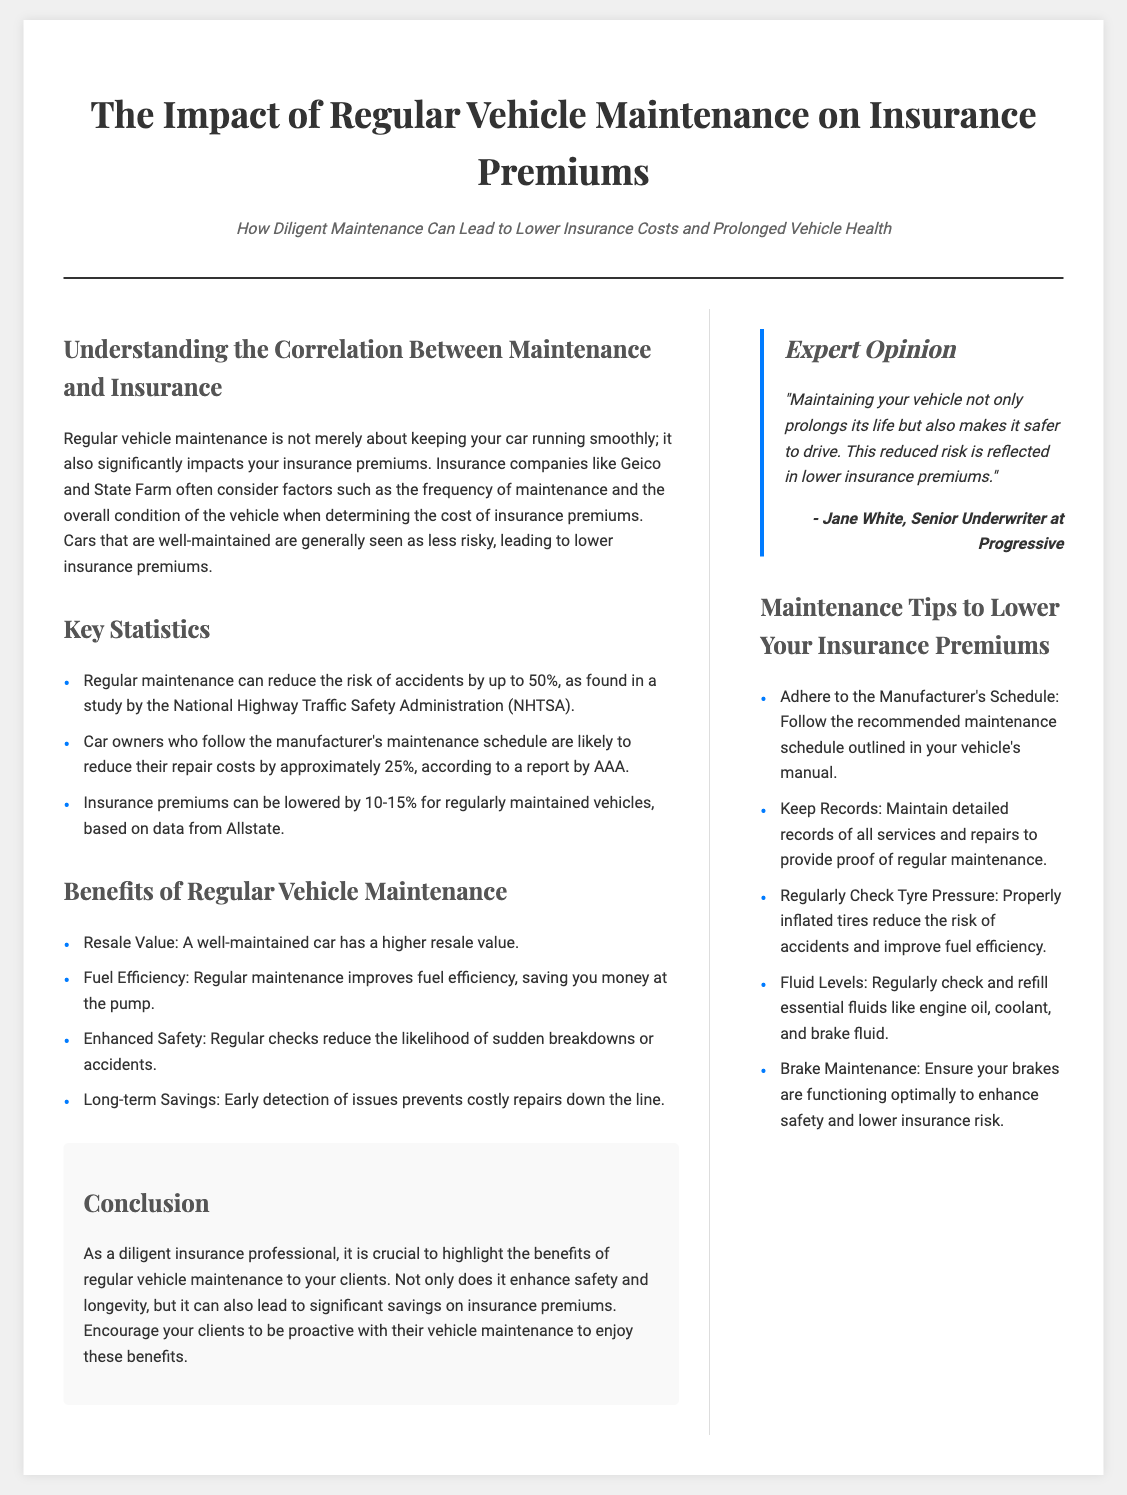what is the title of the article? The title of the article is the main heading of the document.
Answer: The Impact of Regular Vehicle Maintenance on Insurance Premiums who is quoted in the expert opinion section? The quote section includes the name of the person providing their opinion.
Answer: Jane White what percentage can insurance premiums be lowered for regularly maintained vehicles? This statistic is mentioned in the document related to insurance premiums for well-maintained vehicles.
Answer: 10-15% what organization found that regular maintenance can reduce the risk of accidents? The organization cited regarding the reduced risk of accidents due to regular maintenance.
Answer: National Highway Traffic Safety Administration what is one benefit of regular vehicle maintenance mentioned in the document? The document lists various benefits of regular maintenance under a specific section.
Answer: Enhanced Safety how much can following the manufacturer's maintenance schedule reduce repair costs? The document specifies an amount related to how much repair costs can be decreased by following the maintenance schedule.
Answer: approximately 25% what is the subheadline of the article? The subheadline provides additional context regarding the article's focus.
Answer: How Diligent Maintenance Can Lead to Lower Insurance Costs and Prolonged Vehicle Health how many key statistics are presented in the statistics section? The statistics section lists a specific number of statistics relevant to vehicle maintenance and insurance.
Answer: 3 